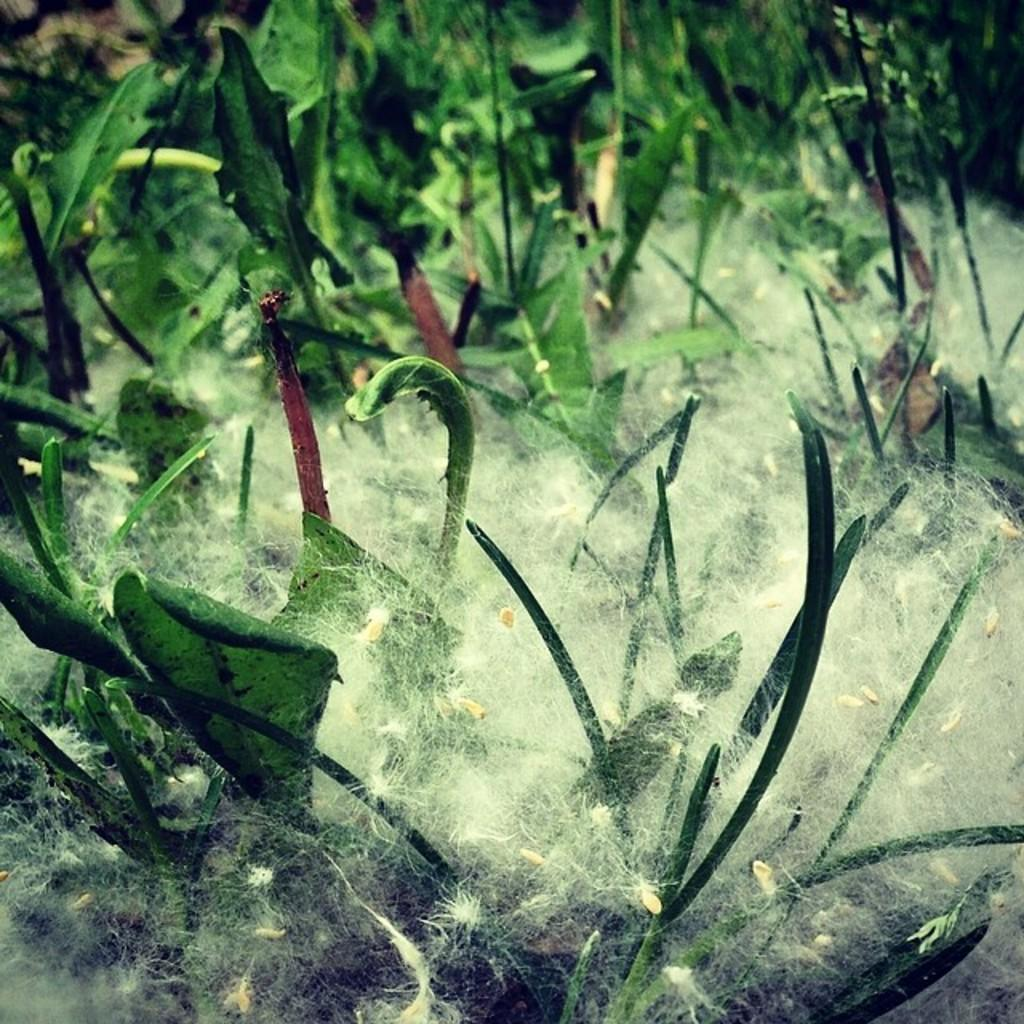What type of plants are in the foreground of the image? There are weed plants in the foreground of the image. What can be seen on the weed plants? The weed plants have white cotton on them. What type of snakes can be seen slithering through the weed plants in the image? There are no snakes present in the image; it only features weed plants with white cotton on them. 